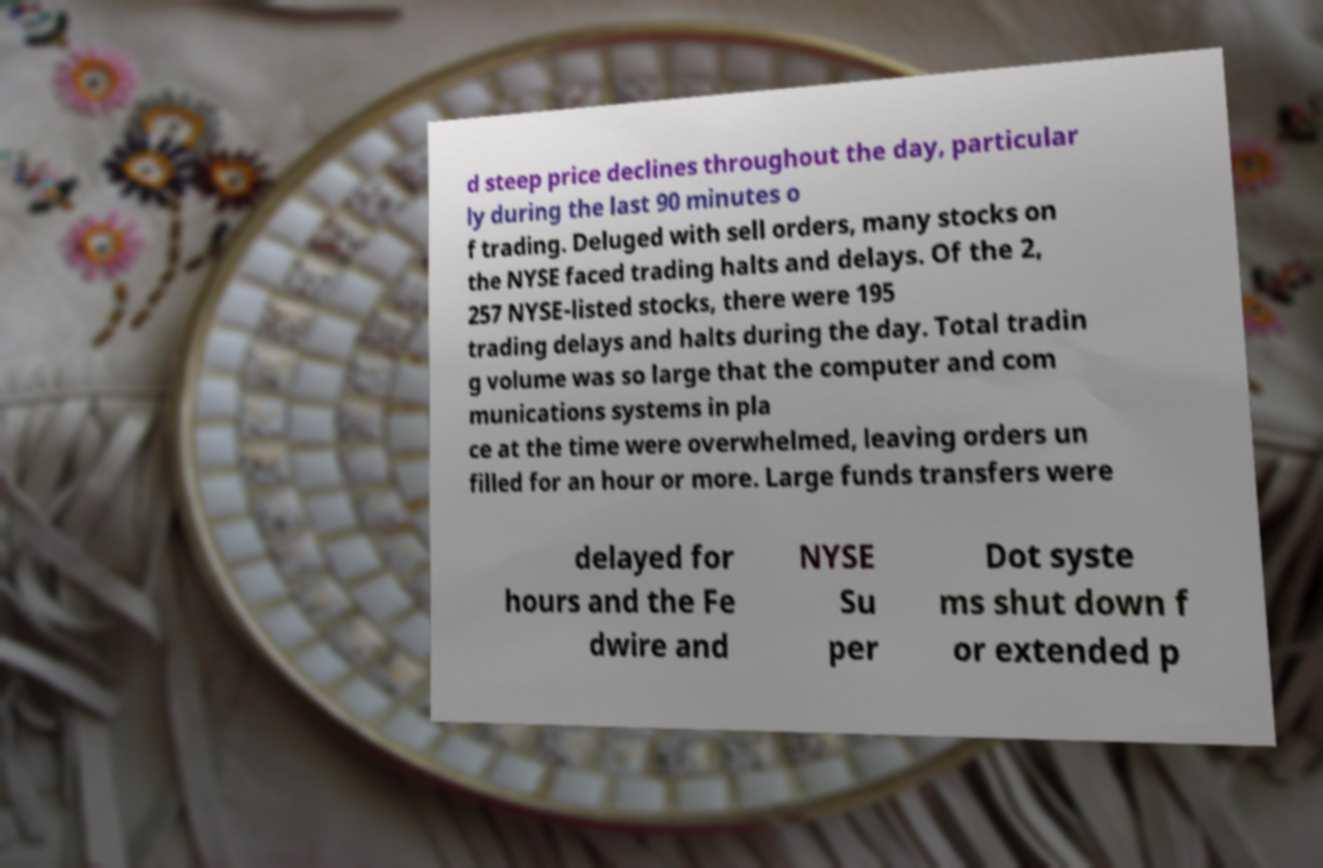For documentation purposes, I need the text within this image transcribed. Could you provide that? d steep price declines throughout the day, particular ly during the last 90 minutes o f trading. Deluged with sell orders, many stocks on the NYSE faced trading halts and delays. Of the 2, 257 NYSE-listed stocks, there were 195 trading delays and halts during the day. Total tradin g volume was so large that the computer and com munications systems in pla ce at the time were overwhelmed, leaving orders un filled for an hour or more. Large funds transfers were delayed for hours and the Fe dwire and NYSE Su per Dot syste ms shut down f or extended p 